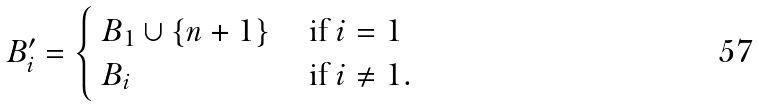<formula> <loc_0><loc_0><loc_500><loc_500>\ B _ { i } ^ { \prime } = \begin{cases} \ B _ { 1 } \cup \{ n + 1 \} & \text { if } i = 1 \\ \ B _ { i } & \text { if } i \ne 1 . \end{cases}</formula> 